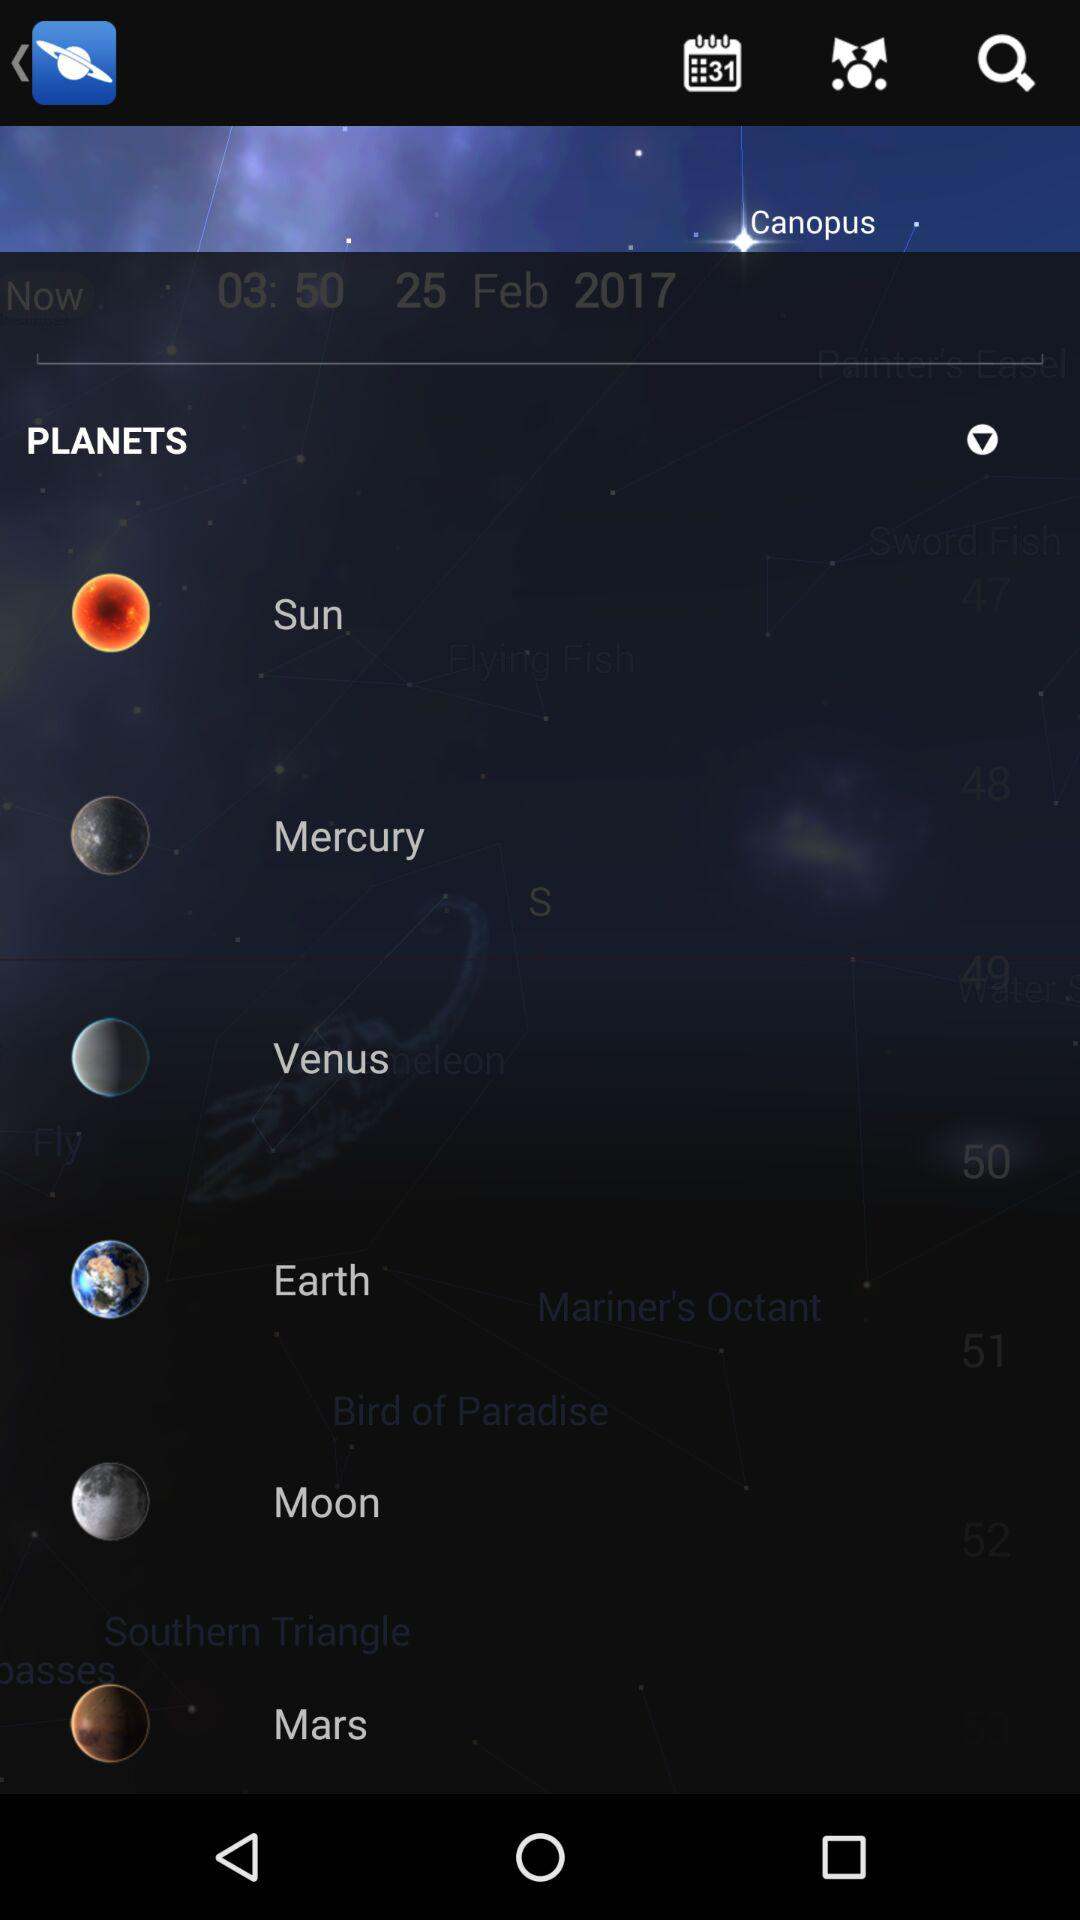What are the given planet names? The given planet names are Mercury, Venus, Earth and Mars. 